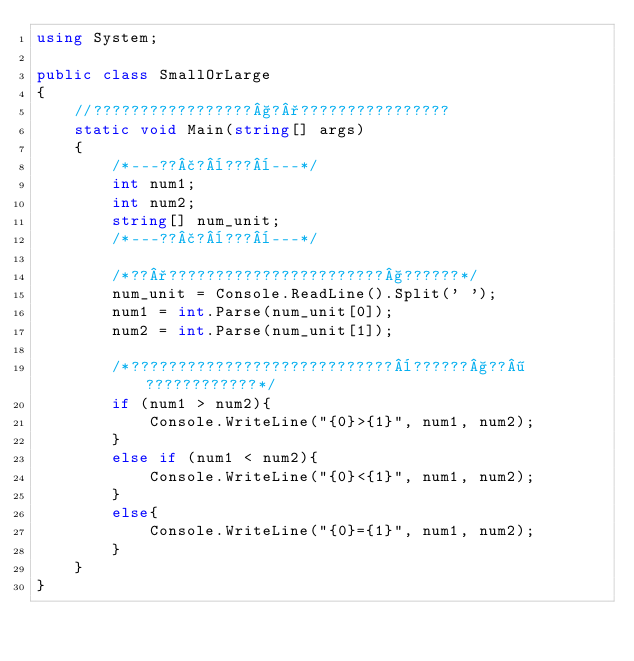Convert code to text. <code><loc_0><loc_0><loc_500><loc_500><_C#_>using System;

public class SmallOrLarge
{
    //?????????????????§?°????????????????
    static void Main(string[] args)
    {
        /*---??£?¨???¨---*/
        int num1;
        int num2;
        string[] num_unit;
        /*---??£?¨???¨---*/

        /*??°???????????????????????§??????*/
        num_unit = Console.ReadLine().Split(' ');
        num1 = int.Parse(num_unit[0]);
        num2 = int.Parse(num_unit[1]);

        /*????????????????????????????¨??????§??¶????????????*/
        if (num1 > num2){
            Console.WriteLine("{0}>{1}", num1, num2);
        }
        else if (num1 < num2){
            Console.WriteLine("{0}<{1}", num1, num2);
        }
        else{
            Console.WriteLine("{0}={1}", num1, num2);
        }
    }
}</code> 